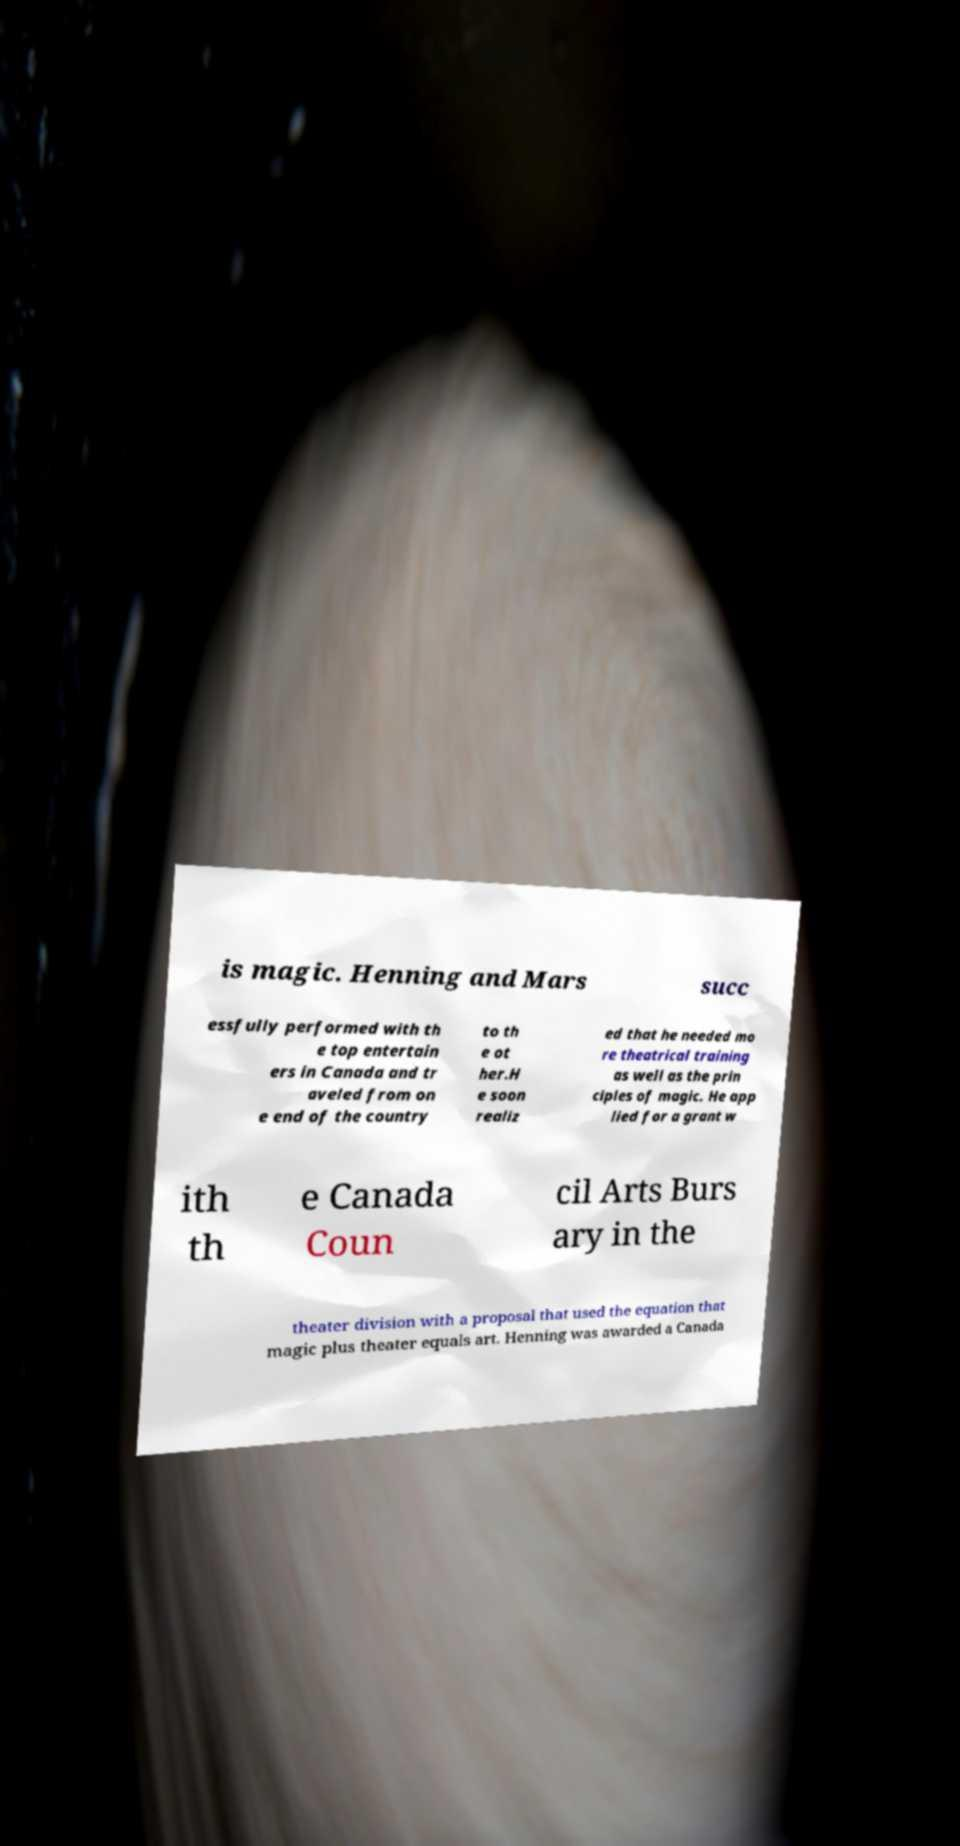Can you accurately transcribe the text from the provided image for me? is magic. Henning and Mars succ essfully performed with th e top entertain ers in Canada and tr aveled from on e end of the country to th e ot her.H e soon realiz ed that he needed mo re theatrical training as well as the prin ciples of magic. He app lied for a grant w ith th e Canada Coun cil Arts Burs ary in the theater division with a proposal that used the equation that magic plus theater equals art. Henning was awarded a Canada 